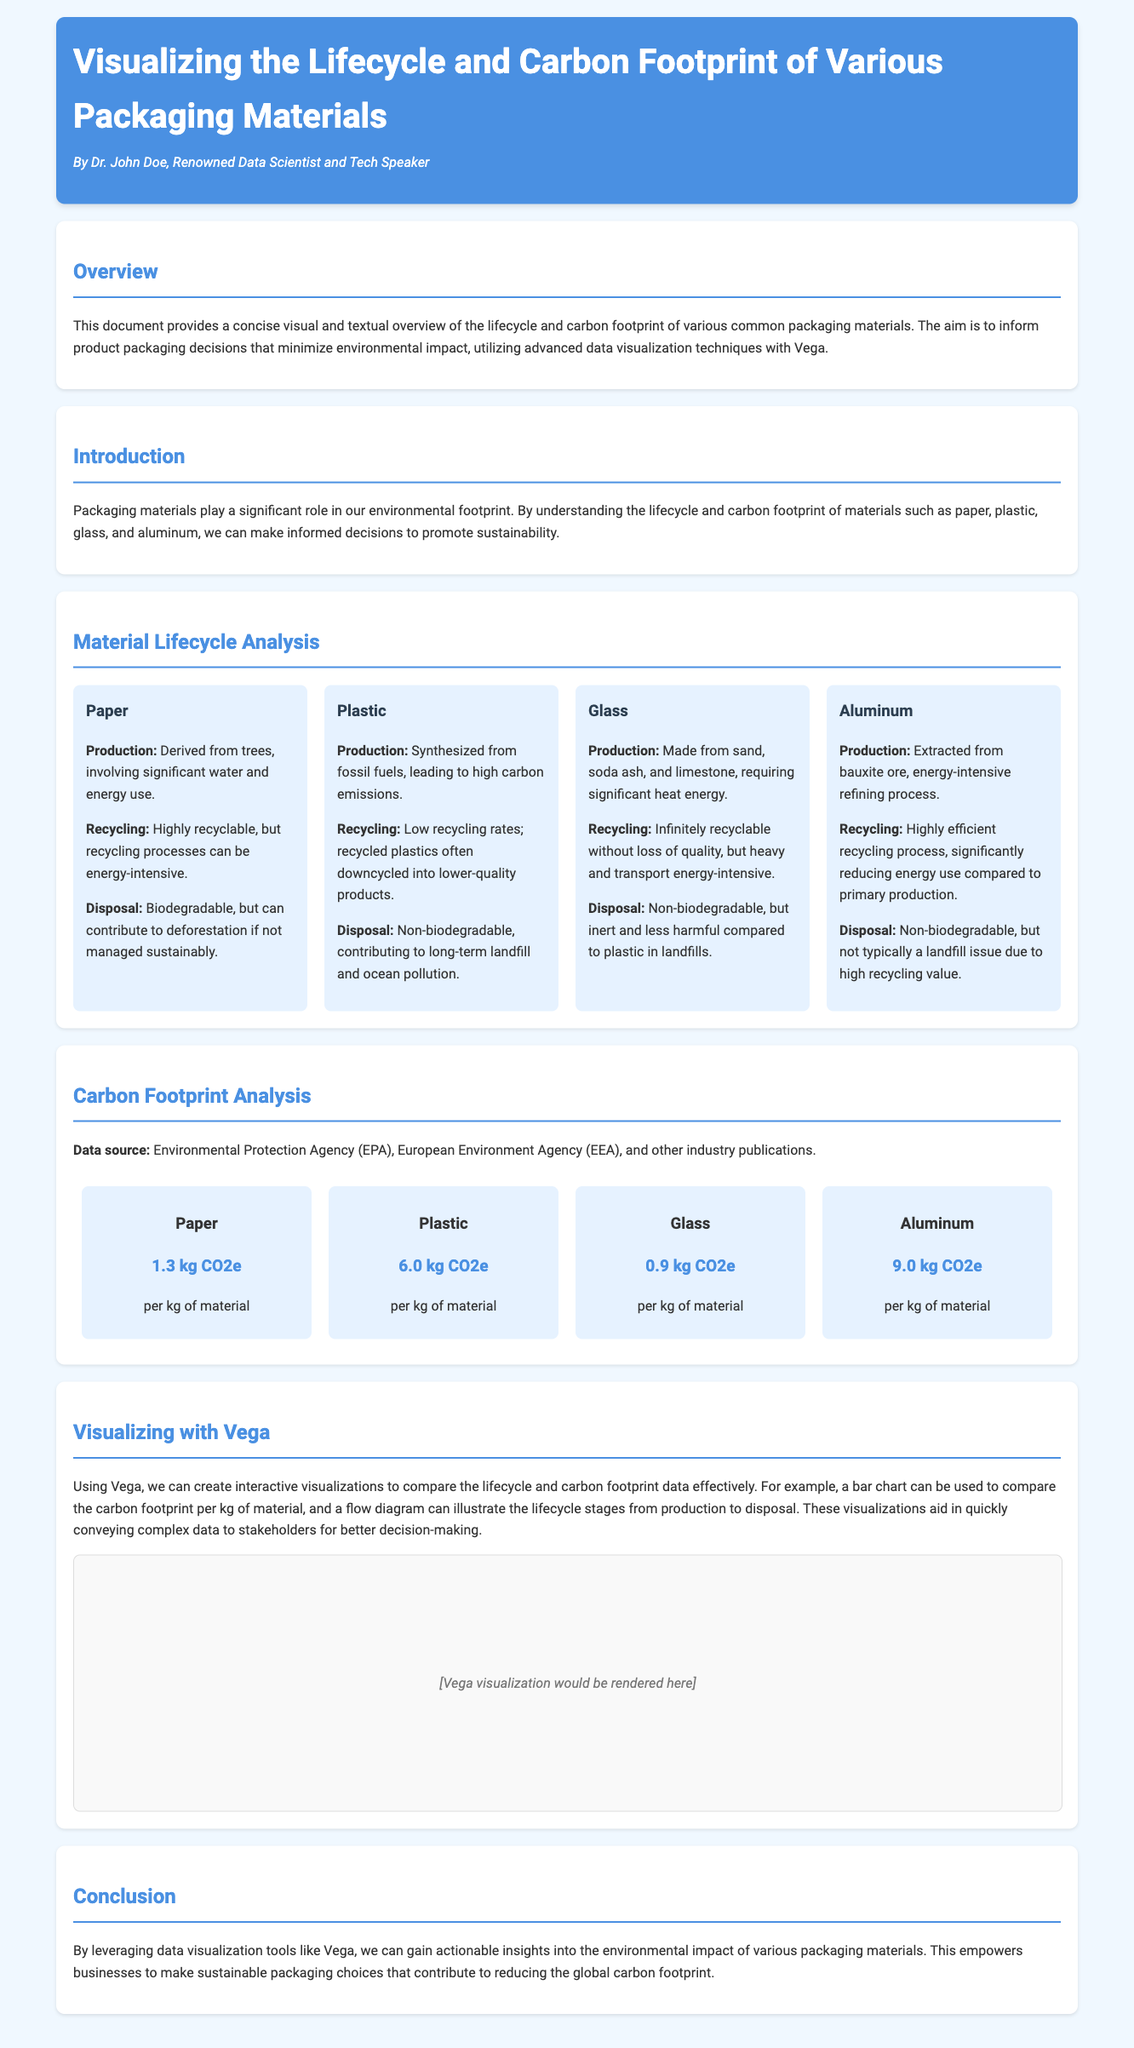What is the carbon footprint of paper? The document states that the carbon footprint of paper is 1.3 kg CO2e per kg of material.
Answer: 1.3 kg CO2e What are the lifecycle stages of plastic? The lifecycle stages of plastic include production, recycling, and disposal, as detailed in the material lifecycle analysis section.
Answer: Production, recycling, disposal Which material is infinitely recyclable? The document indicates that glass is infinitely recyclable without loss of quality.
Answer: Glass What is the carbon footprint of aluminum? The document specifies that the carbon footprint of aluminum is 9.0 kg CO2e per kg of material.
Answer: 9.0 kg CO2e What technology is used for visualizations in the document? The document mentions using Vega as the technology for creating visualizations.
Answer: Vega How does paper disposal contribute to the environment? The document explains that paper is biodegradable but can contribute to deforestation if not managed sustainably.
Answer: Deforestation Which material has the highest carbon footprint? Based on the data displayed, aluminum has the highest carbon footprint compared to other materials.
Answer: Aluminum What is the purpose of this document? The document aims to inform product packaging decisions that minimize environmental impact.
Answer: Minimize environmental impact 